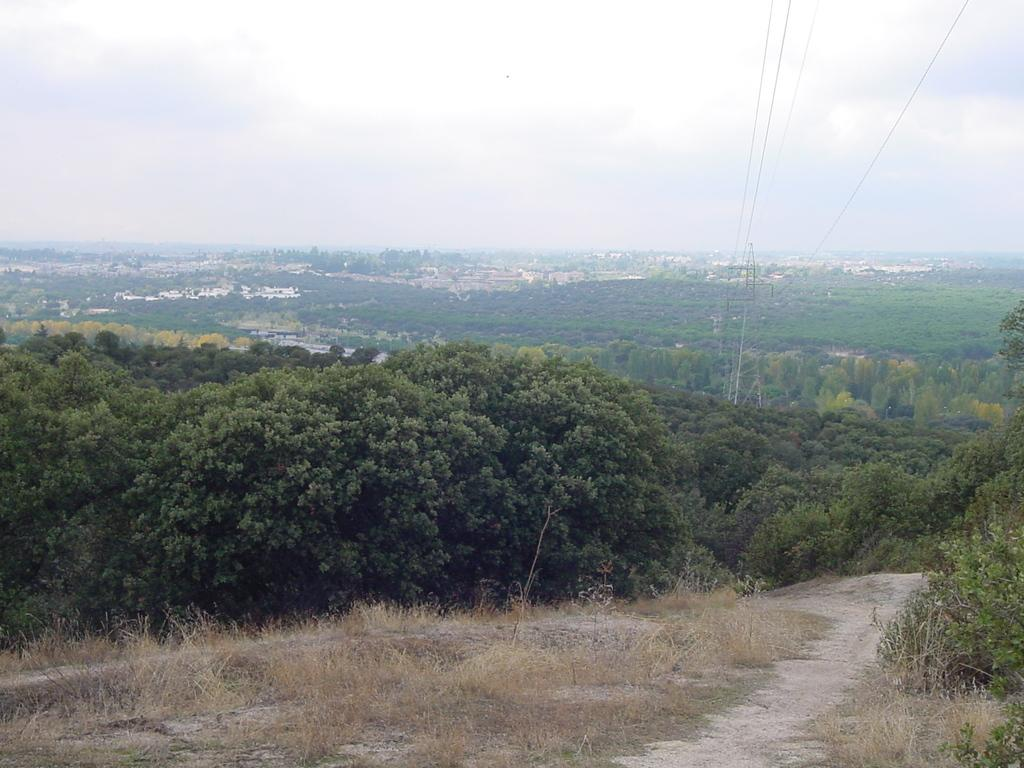What type of vegetation can be seen in the image? There are trees in the image. What type of structures are present in the image? There are buildings in the image. What is covering the ground in the image? There is grass on the ground in the image. What is the condition of the sky in the image? The sky is cloudy in the image. How many toys can be seen on the grass in the image? There are no toys present in the image; it features trees, buildings, grass, and a cloudy sky. Are there any boys playing in the image? There is no mention of boys or any other people in the image. 